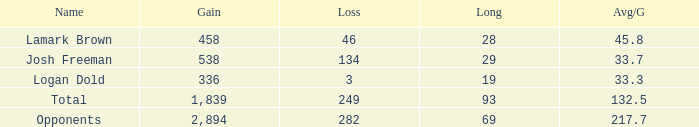Which Avg/G has a Long of 93, and a Loss smaller than 249? None. 